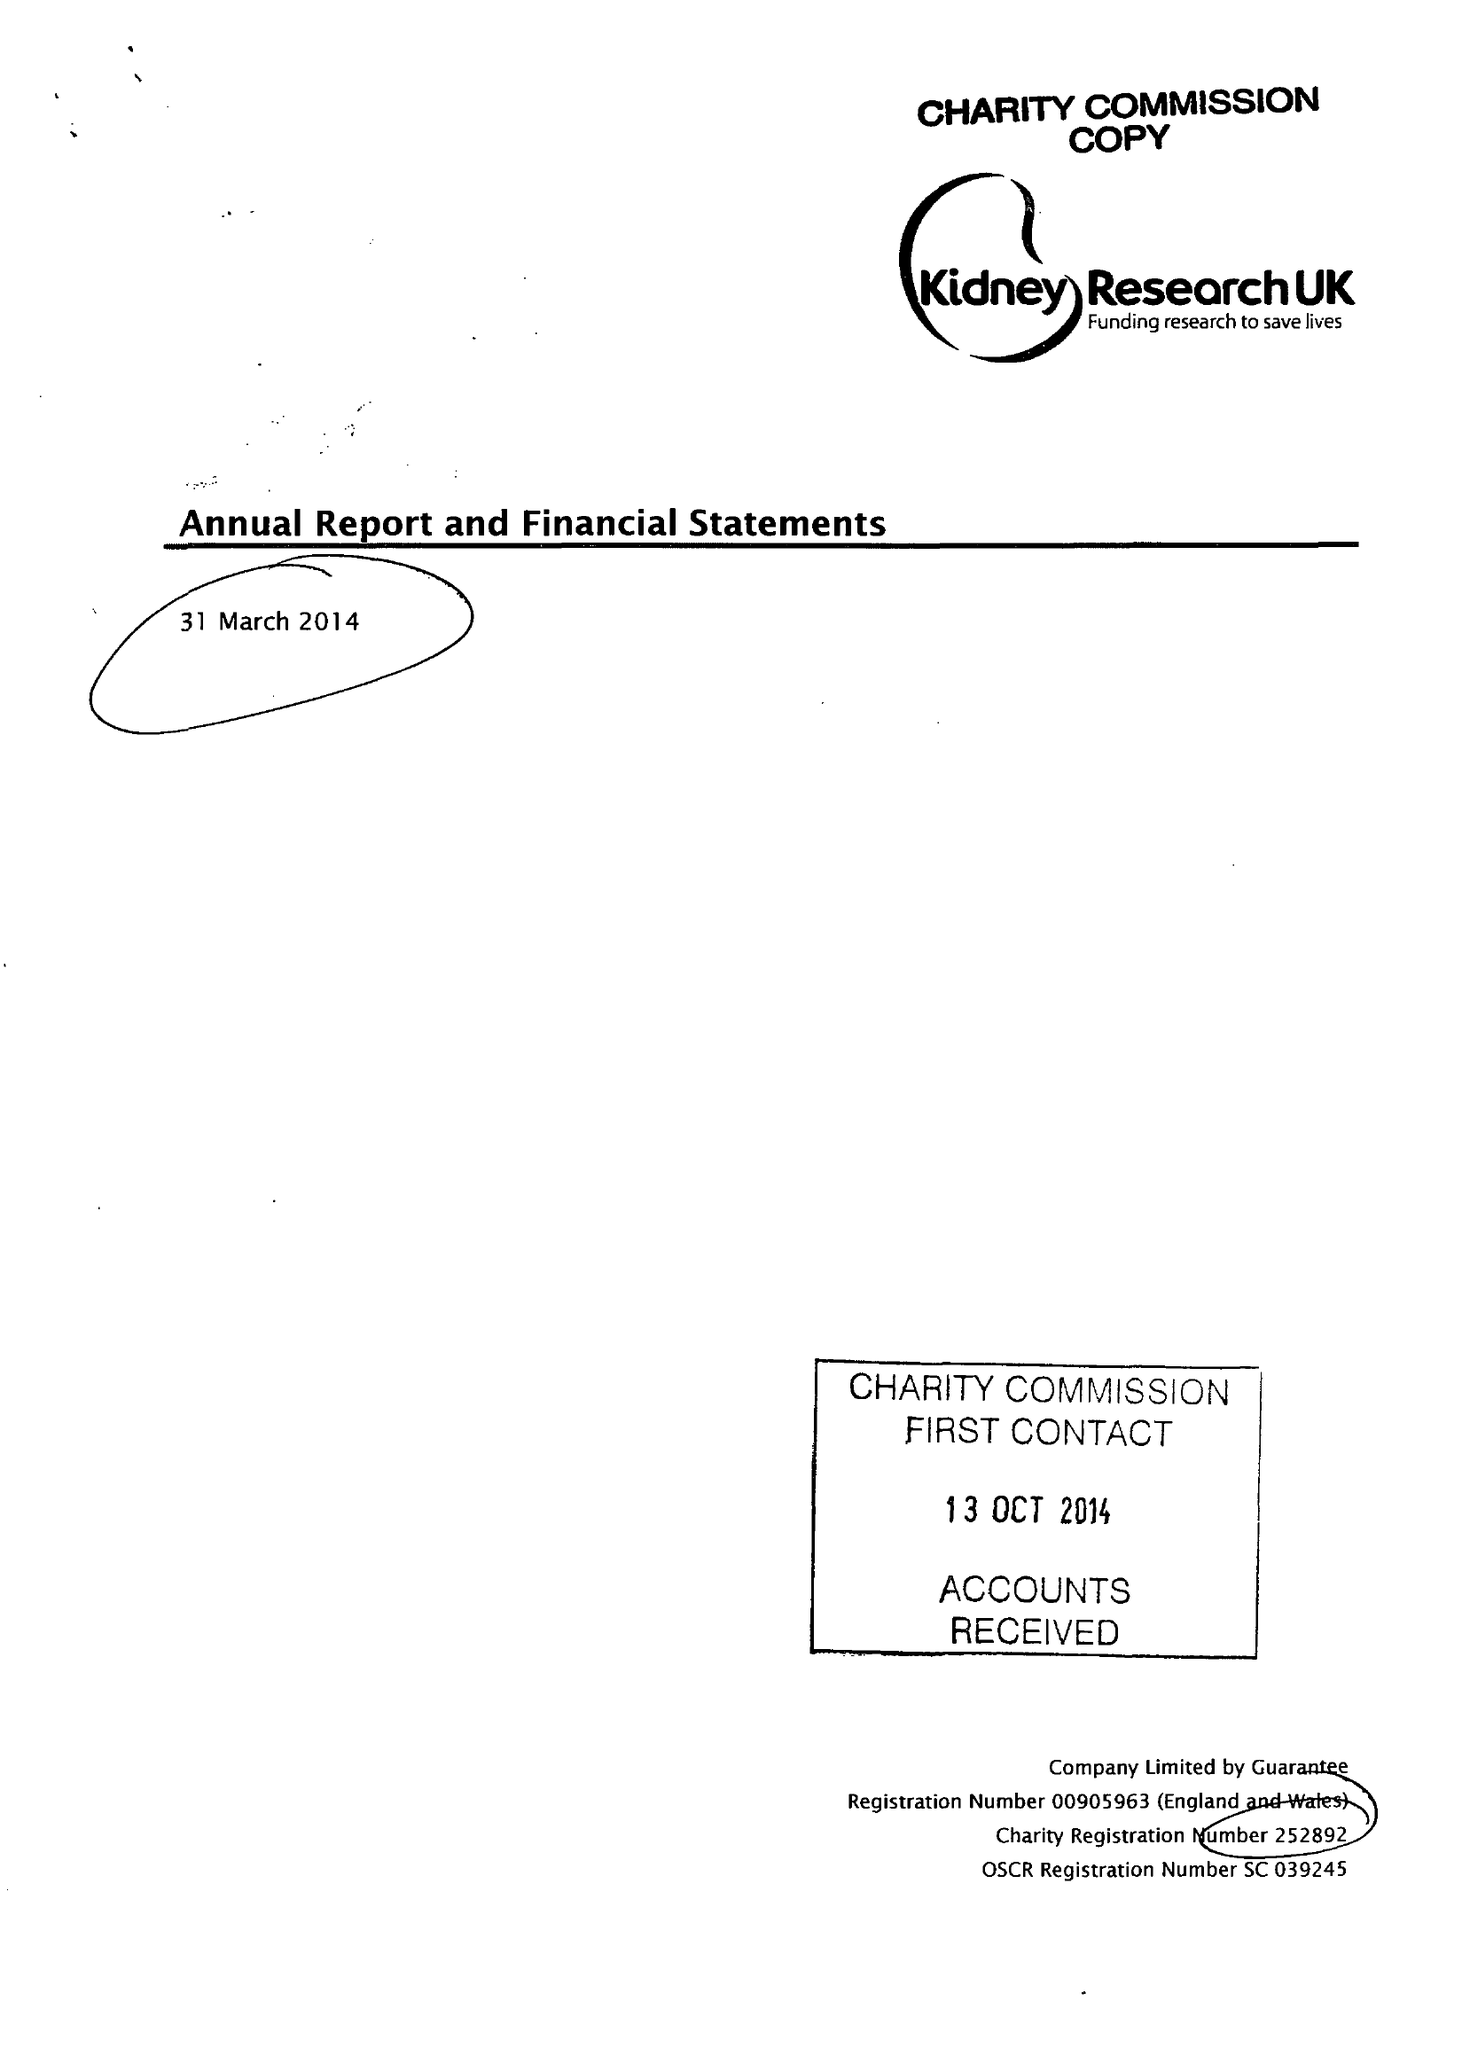What is the value for the address__postcode?
Answer the question using a single word or phrase. PE2 6FZ 